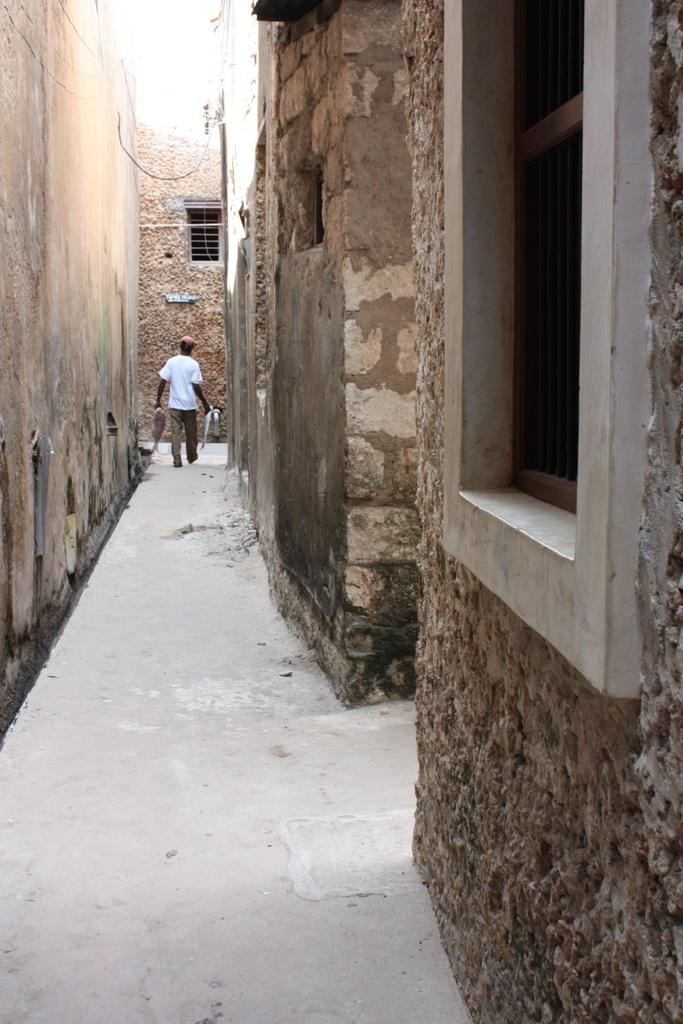What type of path is visible in the image? There is a narrow path in the image. Where is the path situated? The path is located between walls. What type of tent can be seen in the image? There is no tent present in the image; it only features a narrow path between walls. 